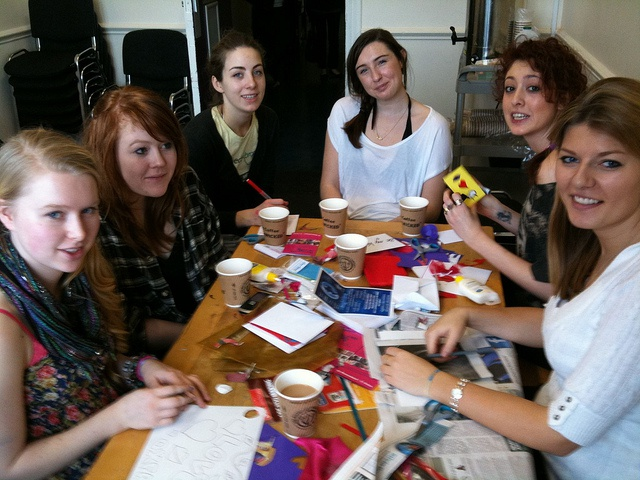Describe the objects in this image and their specific colors. I can see dining table in gray, lightgray, olive, darkgray, and maroon tones, people in gray, lavender, black, and lightblue tones, people in gray, black, and darkgray tones, people in gray, black, maroon, and brown tones, and people in gray, darkgray, black, and lavender tones in this image. 